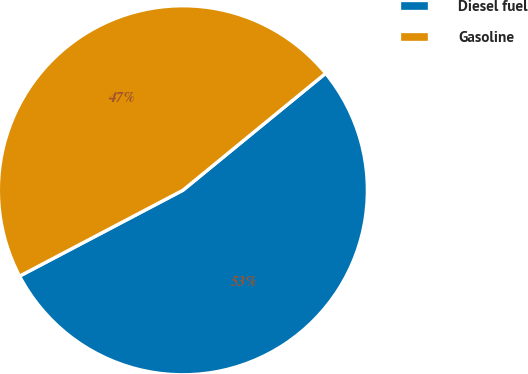Convert chart. <chart><loc_0><loc_0><loc_500><loc_500><pie_chart><fcel>Diesel fuel<fcel>Gasoline<nl><fcel>53.22%<fcel>46.78%<nl></chart> 